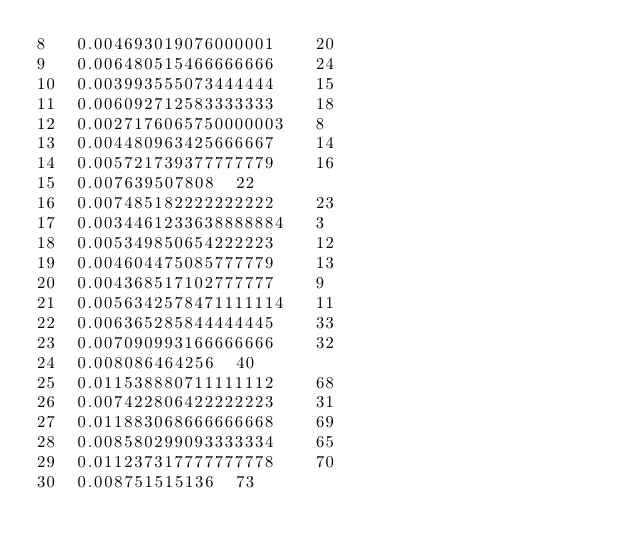Convert code to text. <code><loc_0><loc_0><loc_500><loc_500><_Rust_>8	0.004693019076000001	20
9	0.006480515466666666	24
10	0.003993555073444444	15
11	0.006092712583333333	18
12	0.0027176065750000003	8
13	0.004480963425666667	14
14	0.005721739377777779	16
15	0.007639507808	22
16	0.007485182222222222	23
17	0.0034461233638888884	3
18	0.005349850654222223	12
19	0.004604475085777779	13
20	0.004368517102777777	9
21	0.0056342578471111114	11
22	0.006365285844444445	33
23	0.007090993166666666	32
24	0.008086464256	40
25	0.011538880711111112	68
26	0.007422806422222223	31
27	0.011883068666666668	69
28	0.008580299093333334	65
29	0.011237317777777778	70
30	0.008751515136	73
</code> 